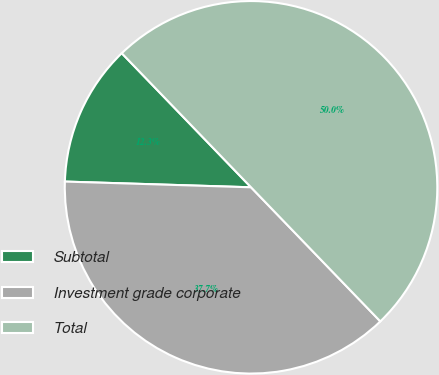<chart> <loc_0><loc_0><loc_500><loc_500><pie_chart><fcel>Subtotal<fcel>Investment grade corporate<fcel>Total<nl><fcel>12.3%<fcel>37.7%<fcel>50.0%<nl></chart> 